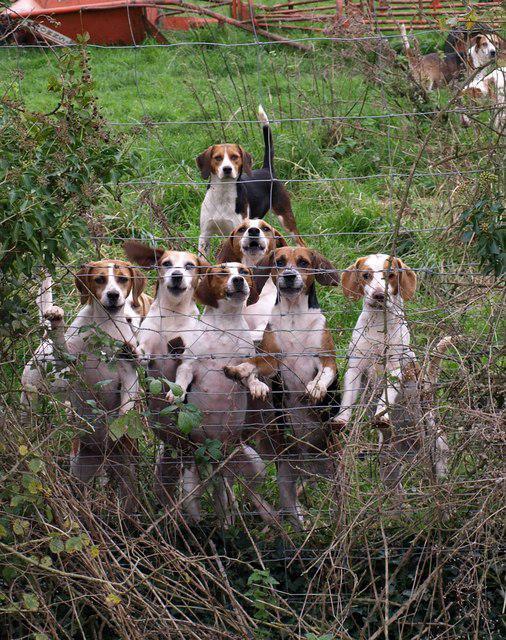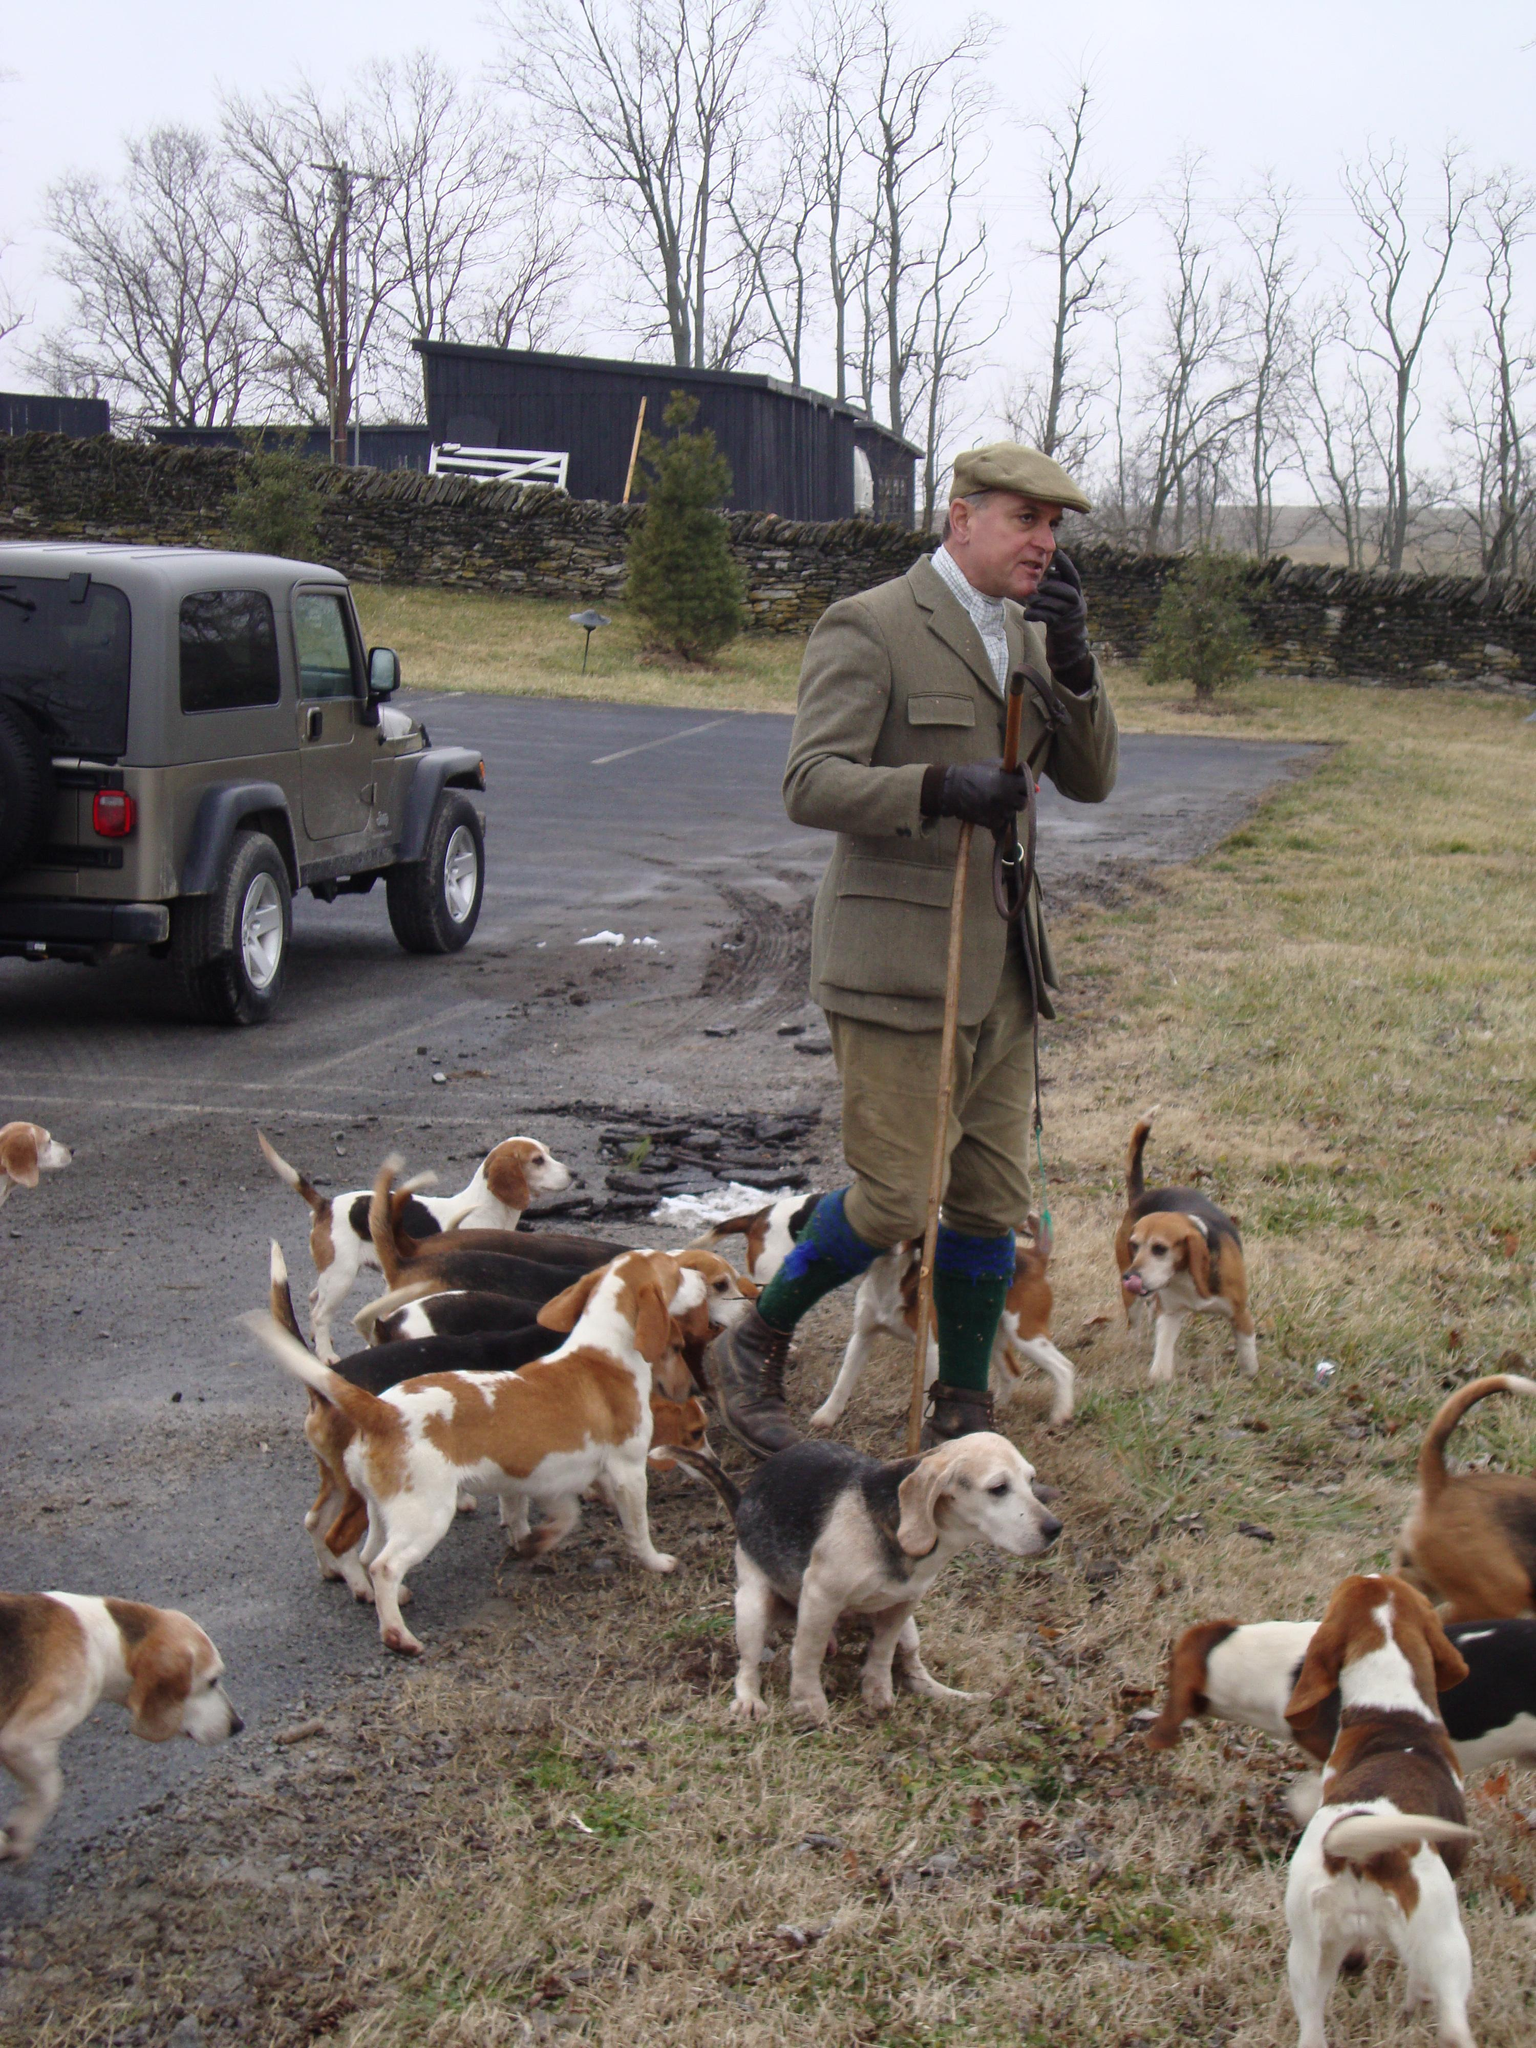The first image is the image on the left, the second image is the image on the right. Given the left and right images, does the statement "One of the images shows a single man surrounded by a group of hunting dogs." hold true? Answer yes or no. Yes. The first image is the image on the left, the second image is the image on the right. Given the left and right images, does the statement "There is no more than one human in the right image." hold true? Answer yes or no. Yes. 